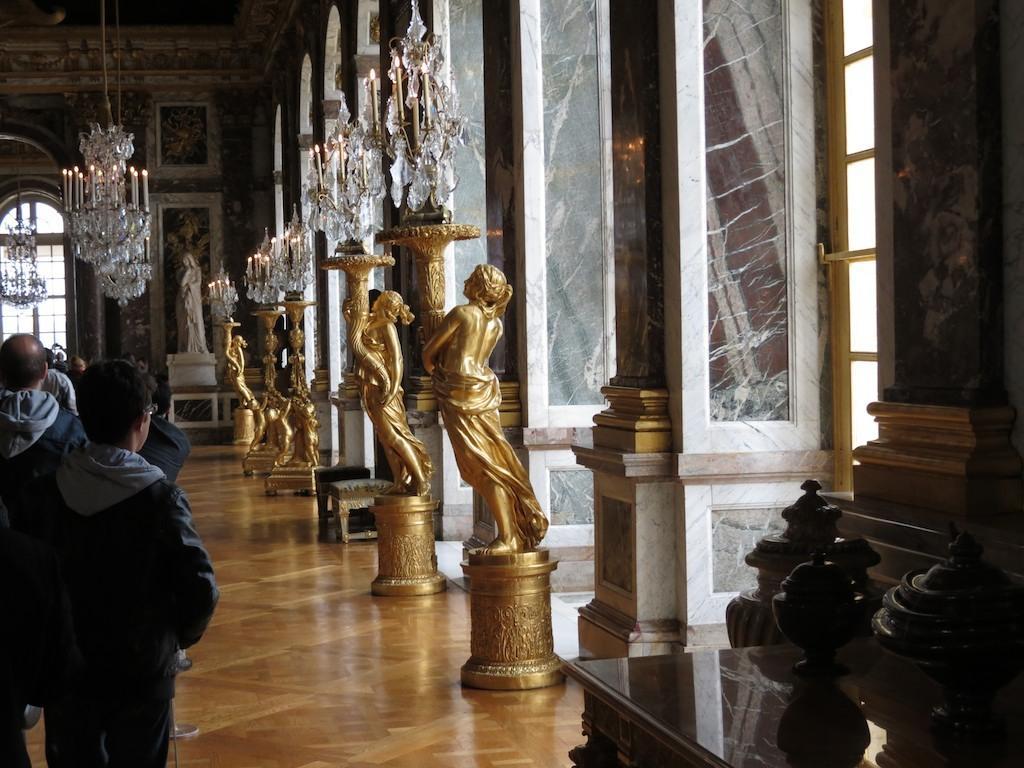How would you summarize this image in a sentence or two? In this image I can see few golden colour sculptures. I can also see few people are standing and I can see they are wearing jackets. In the background I can see number of candles and I can see one more white colour sculpture over there. 